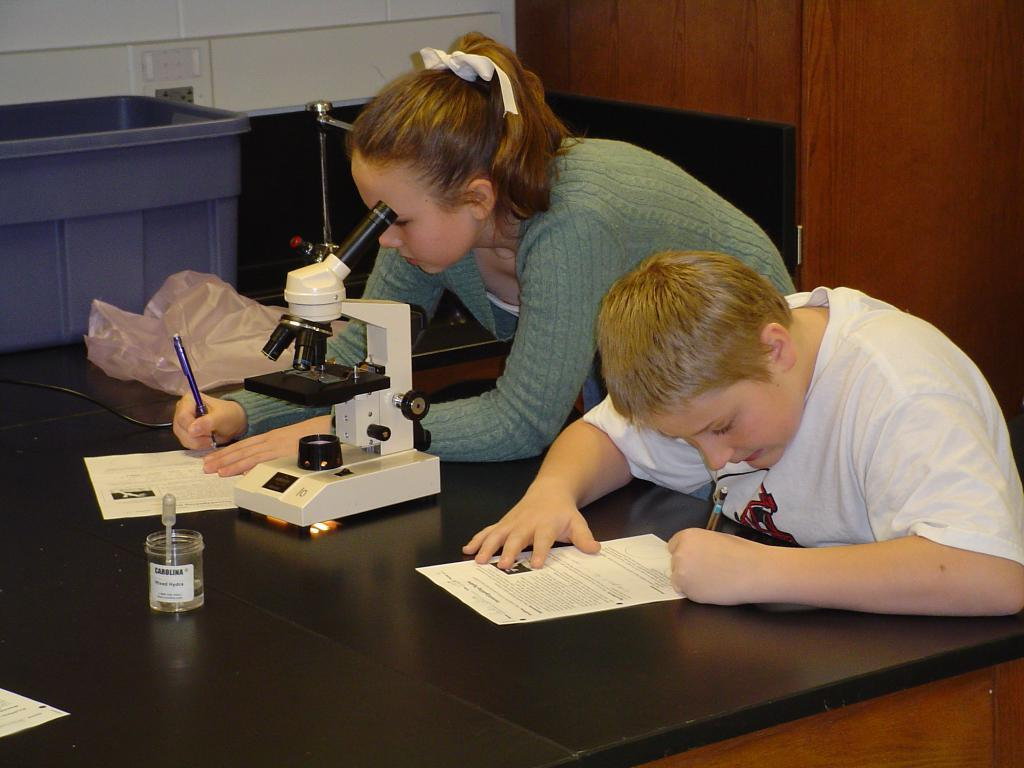What is the boy in the image doing? The boy is sitting and holding a pen in his hand. What is the boy possibly about to do with the pen? The boy might be about to write on the paper, as there is a pen in his hand. What is the girl in the image doing? The girl is standing and writing on the paper. What is the girl possibly using to write on the paper? The girl is using a pen, as the boy is also holding a pen in his hand. What type of joke is the boy telling the girl in the image? There is no joke being told in the image; the boy is sitting and holding a pen, while the girl is standing and writing on the paper. Can you tell me how the hose is connected to the table in the image? There is no hose present in the image; the objects on the table include a paper and other unspecified items. 